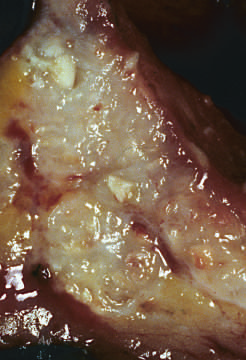re acute tubular epithelial cell injury with blebbing at the luminal pole, detachment of tubular cells from their underlying basement membranes, and granular present within the colon wall?
Answer the question using a single word or phrase. No 